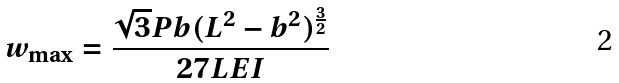Convert formula to latex. <formula><loc_0><loc_0><loc_500><loc_500>w _ { \max } = { \frac { { \sqrt { 3 } } P b ( L ^ { 2 } - b ^ { 2 } ) ^ { \frac { 3 } { 2 } } } { 2 7 L E I } }</formula> 